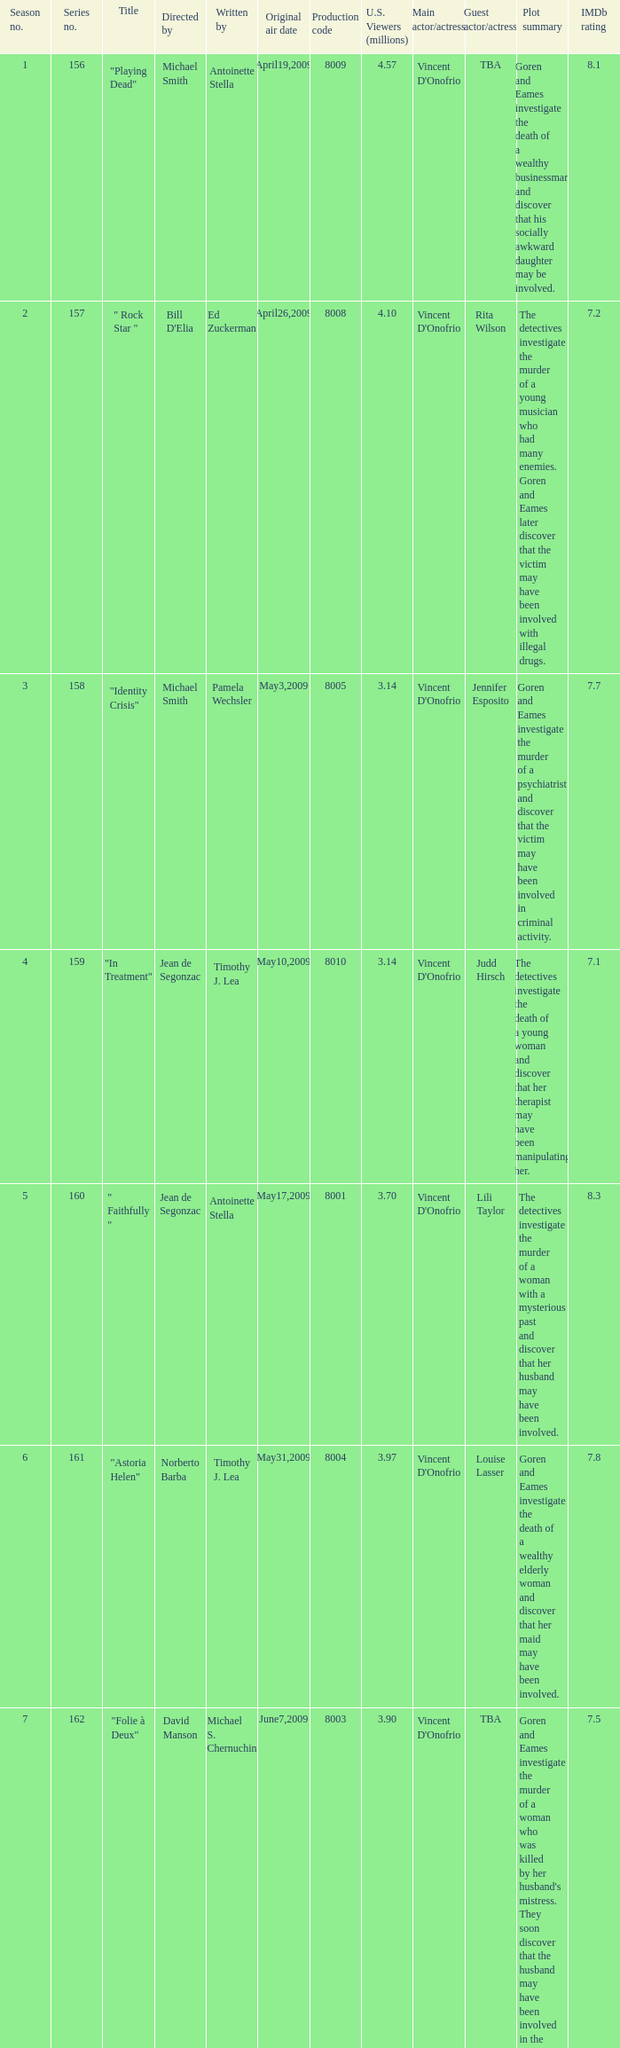Who are the writers when the production code is 8011? Michael S. Chernuchin. 